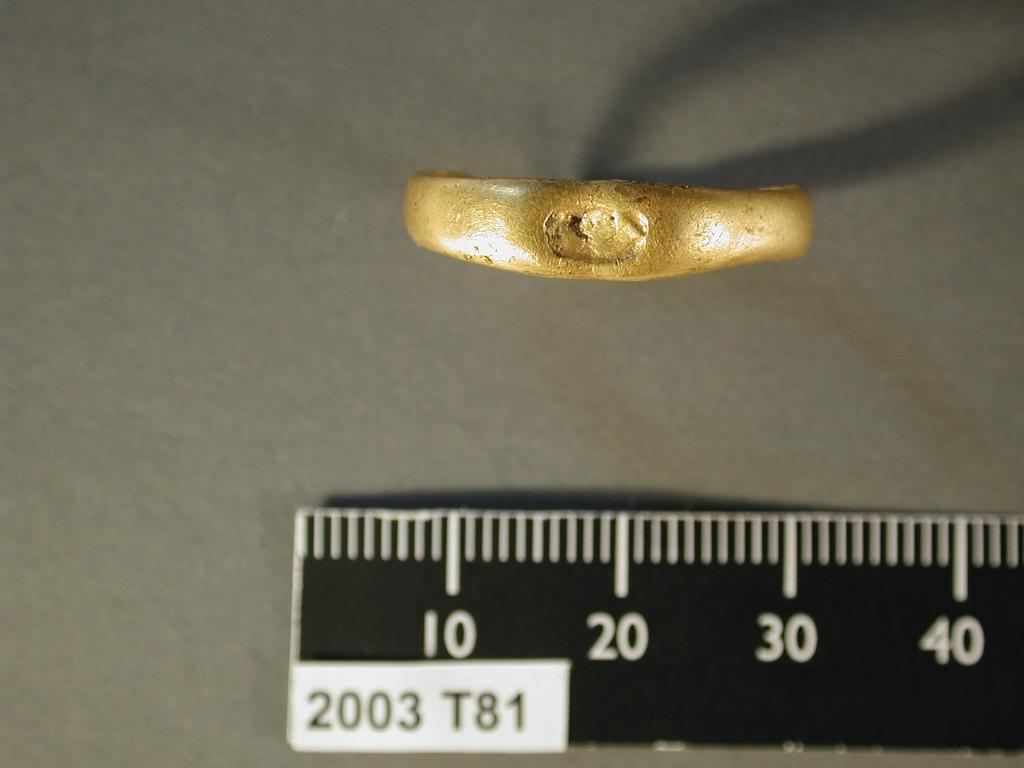<image>
Relay a brief, clear account of the picture shown. a ruler with 2003 T81 on it measures an object 